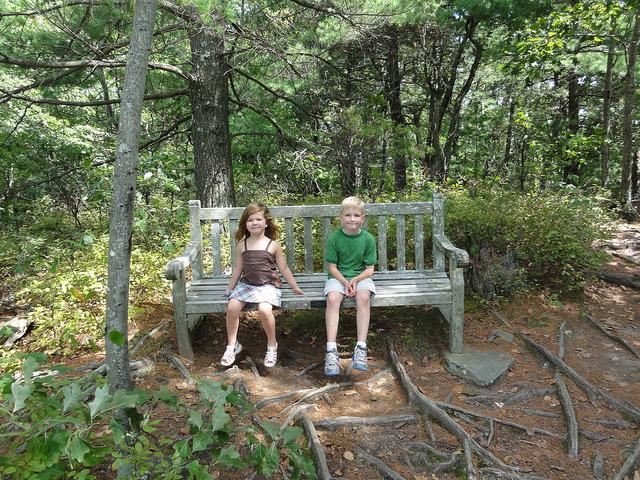What could likely happen to you on this bench? Please explain your reasoning. get sunburn. The kids are likely to get sunburn while sitting on the bench. 